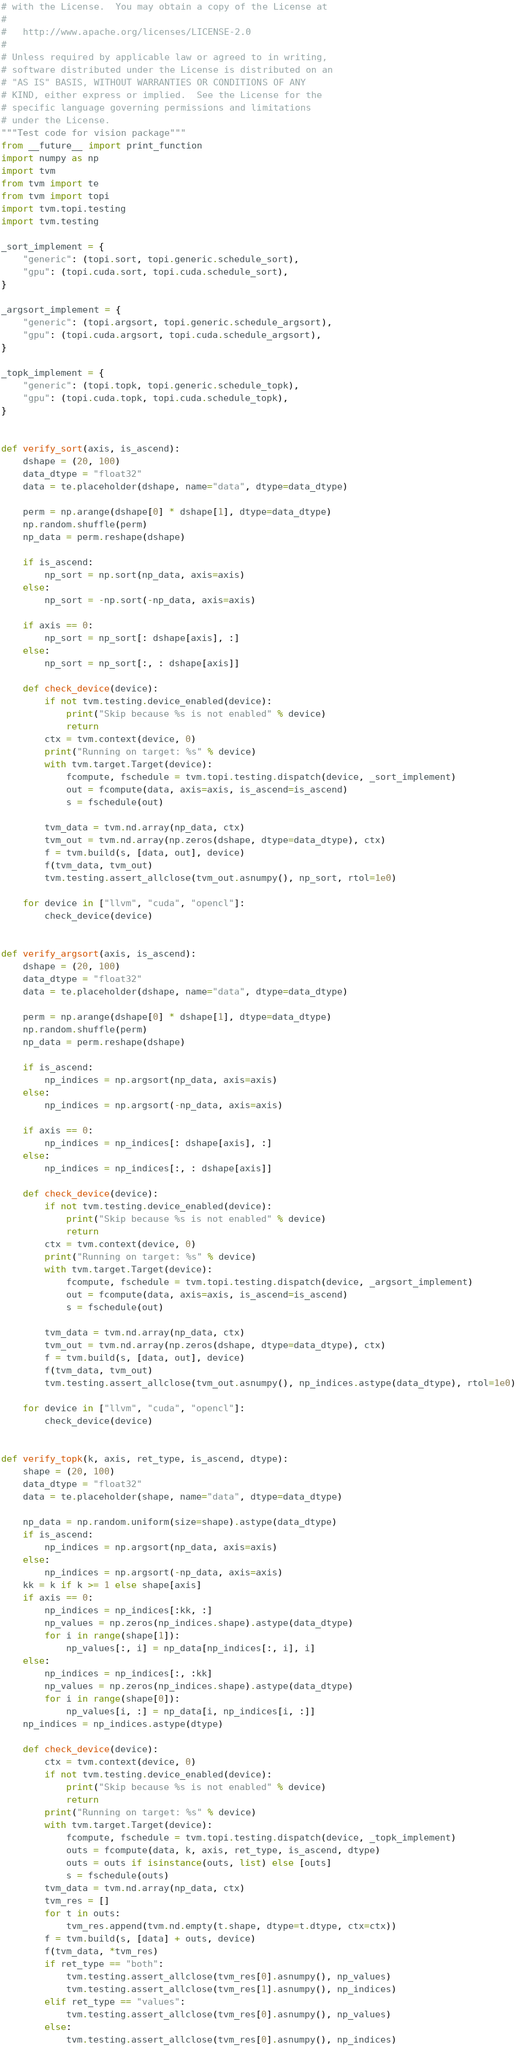<code> <loc_0><loc_0><loc_500><loc_500><_Python_># with the License.  You may obtain a copy of the License at
#
#   http://www.apache.org/licenses/LICENSE-2.0
#
# Unless required by applicable law or agreed to in writing,
# software distributed under the License is distributed on an
# "AS IS" BASIS, WITHOUT WARRANTIES OR CONDITIONS OF ANY
# KIND, either express or implied.  See the License for the
# specific language governing permissions and limitations
# under the License.
"""Test code for vision package"""
from __future__ import print_function
import numpy as np
import tvm
from tvm import te
from tvm import topi
import tvm.topi.testing
import tvm.testing

_sort_implement = {
    "generic": (topi.sort, topi.generic.schedule_sort),
    "gpu": (topi.cuda.sort, topi.cuda.schedule_sort),
}

_argsort_implement = {
    "generic": (topi.argsort, topi.generic.schedule_argsort),
    "gpu": (topi.cuda.argsort, topi.cuda.schedule_argsort),
}

_topk_implement = {
    "generic": (topi.topk, topi.generic.schedule_topk),
    "gpu": (topi.cuda.topk, topi.cuda.schedule_topk),
}


def verify_sort(axis, is_ascend):
    dshape = (20, 100)
    data_dtype = "float32"
    data = te.placeholder(dshape, name="data", dtype=data_dtype)

    perm = np.arange(dshape[0] * dshape[1], dtype=data_dtype)
    np.random.shuffle(perm)
    np_data = perm.reshape(dshape)

    if is_ascend:
        np_sort = np.sort(np_data, axis=axis)
    else:
        np_sort = -np.sort(-np_data, axis=axis)

    if axis == 0:
        np_sort = np_sort[: dshape[axis], :]
    else:
        np_sort = np_sort[:, : dshape[axis]]

    def check_device(device):
        if not tvm.testing.device_enabled(device):
            print("Skip because %s is not enabled" % device)
            return
        ctx = tvm.context(device, 0)
        print("Running on target: %s" % device)
        with tvm.target.Target(device):
            fcompute, fschedule = tvm.topi.testing.dispatch(device, _sort_implement)
            out = fcompute(data, axis=axis, is_ascend=is_ascend)
            s = fschedule(out)

        tvm_data = tvm.nd.array(np_data, ctx)
        tvm_out = tvm.nd.array(np.zeros(dshape, dtype=data_dtype), ctx)
        f = tvm.build(s, [data, out], device)
        f(tvm_data, tvm_out)
        tvm.testing.assert_allclose(tvm_out.asnumpy(), np_sort, rtol=1e0)

    for device in ["llvm", "cuda", "opencl"]:
        check_device(device)


def verify_argsort(axis, is_ascend):
    dshape = (20, 100)
    data_dtype = "float32"
    data = te.placeholder(dshape, name="data", dtype=data_dtype)

    perm = np.arange(dshape[0] * dshape[1], dtype=data_dtype)
    np.random.shuffle(perm)
    np_data = perm.reshape(dshape)

    if is_ascend:
        np_indices = np.argsort(np_data, axis=axis)
    else:
        np_indices = np.argsort(-np_data, axis=axis)

    if axis == 0:
        np_indices = np_indices[: dshape[axis], :]
    else:
        np_indices = np_indices[:, : dshape[axis]]

    def check_device(device):
        if not tvm.testing.device_enabled(device):
            print("Skip because %s is not enabled" % device)
            return
        ctx = tvm.context(device, 0)
        print("Running on target: %s" % device)
        with tvm.target.Target(device):
            fcompute, fschedule = tvm.topi.testing.dispatch(device, _argsort_implement)
            out = fcompute(data, axis=axis, is_ascend=is_ascend)
            s = fschedule(out)

        tvm_data = tvm.nd.array(np_data, ctx)
        tvm_out = tvm.nd.array(np.zeros(dshape, dtype=data_dtype), ctx)
        f = tvm.build(s, [data, out], device)
        f(tvm_data, tvm_out)
        tvm.testing.assert_allclose(tvm_out.asnumpy(), np_indices.astype(data_dtype), rtol=1e0)

    for device in ["llvm", "cuda", "opencl"]:
        check_device(device)


def verify_topk(k, axis, ret_type, is_ascend, dtype):
    shape = (20, 100)
    data_dtype = "float32"
    data = te.placeholder(shape, name="data", dtype=data_dtype)

    np_data = np.random.uniform(size=shape).astype(data_dtype)
    if is_ascend:
        np_indices = np.argsort(np_data, axis=axis)
    else:
        np_indices = np.argsort(-np_data, axis=axis)
    kk = k if k >= 1 else shape[axis]
    if axis == 0:
        np_indices = np_indices[:kk, :]
        np_values = np.zeros(np_indices.shape).astype(data_dtype)
        for i in range(shape[1]):
            np_values[:, i] = np_data[np_indices[:, i], i]
    else:
        np_indices = np_indices[:, :kk]
        np_values = np.zeros(np_indices.shape).astype(data_dtype)
        for i in range(shape[0]):
            np_values[i, :] = np_data[i, np_indices[i, :]]
    np_indices = np_indices.astype(dtype)

    def check_device(device):
        ctx = tvm.context(device, 0)
        if not tvm.testing.device_enabled(device):
            print("Skip because %s is not enabled" % device)
            return
        print("Running on target: %s" % device)
        with tvm.target.Target(device):
            fcompute, fschedule = tvm.topi.testing.dispatch(device, _topk_implement)
            outs = fcompute(data, k, axis, ret_type, is_ascend, dtype)
            outs = outs if isinstance(outs, list) else [outs]
            s = fschedule(outs)
        tvm_data = tvm.nd.array(np_data, ctx)
        tvm_res = []
        for t in outs:
            tvm_res.append(tvm.nd.empty(t.shape, dtype=t.dtype, ctx=ctx))
        f = tvm.build(s, [data] + outs, device)
        f(tvm_data, *tvm_res)
        if ret_type == "both":
            tvm.testing.assert_allclose(tvm_res[0].asnumpy(), np_values)
            tvm.testing.assert_allclose(tvm_res[1].asnumpy(), np_indices)
        elif ret_type == "values":
            tvm.testing.assert_allclose(tvm_res[0].asnumpy(), np_values)
        else:
            tvm.testing.assert_allclose(tvm_res[0].asnumpy(), np_indices)
</code> 